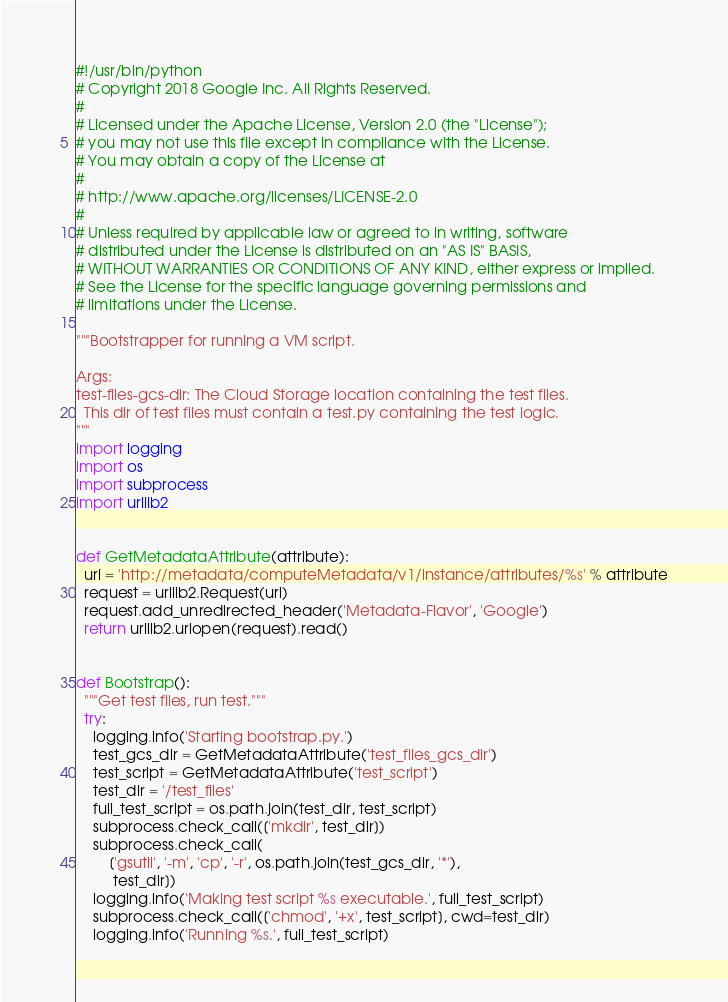<code> <loc_0><loc_0><loc_500><loc_500><_Python_>#!/usr/bin/python
# Copyright 2018 Google Inc. All Rights Reserved.
#
# Licensed under the Apache License, Version 2.0 (the "License");
# you may not use this file except in compliance with the License.
# You may obtain a copy of the License at
#
# http://www.apache.org/licenses/LICENSE-2.0
#
# Unless required by applicable law or agreed to in writing, software
# distributed under the License is distributed on an "AS IS" BASIS,
# WITHOUT WARRANTIES OR CONDITIONS OF ANY KIND, either express or implied.
# See the License for the specific language governing permissions and
# limitations under the License.

"""Bootstrapper for running a VM script.

Args:
test-files-gcs-dir: The Cloud Storage location containing the test files.
  This dir of test files must contain a test.py containing the test logic.
"""
import logging
import os
import subprocess
import urllib2


def GetMetadataAttribute(attribute):
  url = 'http://metadata/computeMetadata/v1/instance/attributes/%s' % attribute
  request = urllib2.Request(url)
  request.add_unredirected_header('Metadata-Flavor', 'Google')
  return urllib2.urlopen(request).read()


def Bootstrap():
  """Get test files, run test."""
  try:
    logging.info('Starting bootstrap.py.')
    test_gcs_dir = GetMetadataAttribute('test_files_gcs_dir')
    test_script = GetMetadataAttribute('test_script')
    test_dir = '/test_files'
    full_test_script = os.path.join(test_dir, test_script)
    subprocess.check_call(['mkdir', test_dir])
    subprocess.check_call(
        ['gsutil', '-m', 'cp', '-r', os.path.join(test_gcs_dir, '*'),
         test_dir])
    logging.info('Making test script %s executable.', full_test_script)
    subprocess.check_call(['chmod', '+x', test_script], cwd=test_dir)
    logging.info('Running %s.', full_test_script)</code> 